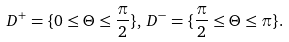<formula> <loc_0><loc_0><loc_500><loc_500>D ^ { + } = \{ 0 \leq \Theta \leq \frac { \pi } { 2 } \} , \, D ^ { - } = \{ \frac { \pi } { 2 } \leq \Theta \leq \pi \} .</formula> 